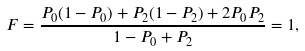Convert formula to latex. <formula><loc_0><loc_0><loc_500><loc_500>F = \frac { P _ { 0 } ( 1 - P _ { 0 } ) + P _ { 2 } ( 1 - P _ { 2 } ) + 2 P _ { 0 } P _ { 2 } } { 1 - P _ { 0 } + P _ { 2 } } = 1 ,</formula> 